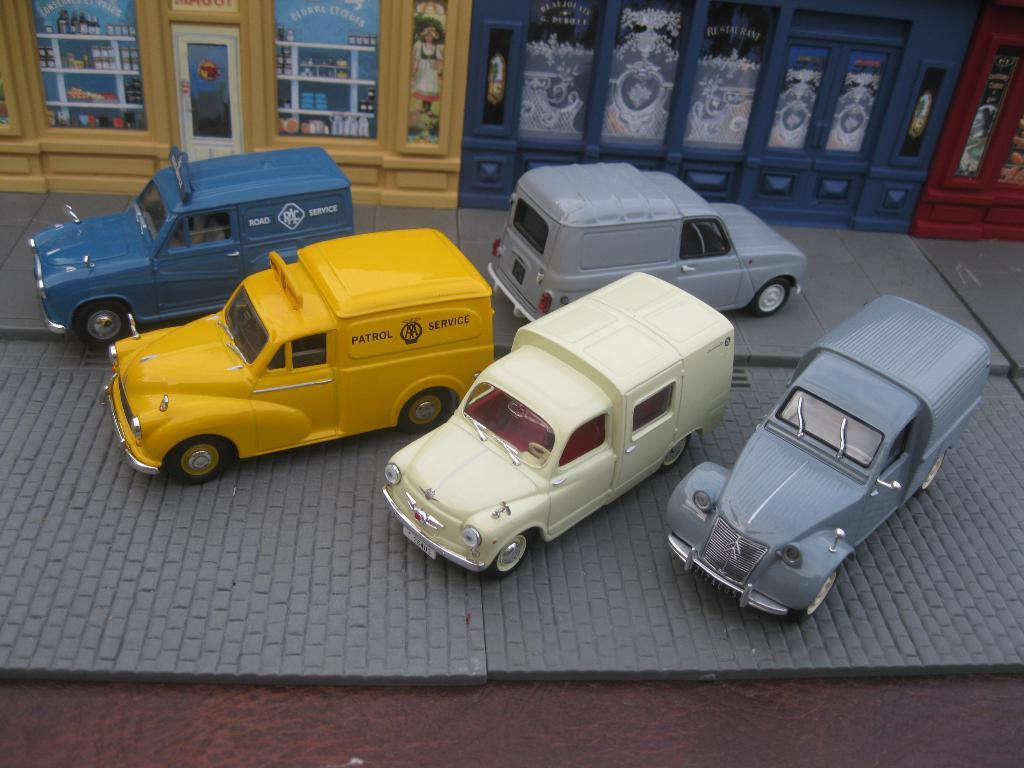What type of structures can be seen in the image? There are buildings in the image. What type of vehicles are present in the image? There are cars with different colors in the image. Can you tell me how many eggs are on top of the buildings in the image? There are no eggs present on top of the buildings in the image. What color is the balloon tied to the car in the image? There is no balloon tied to any car in the image. 